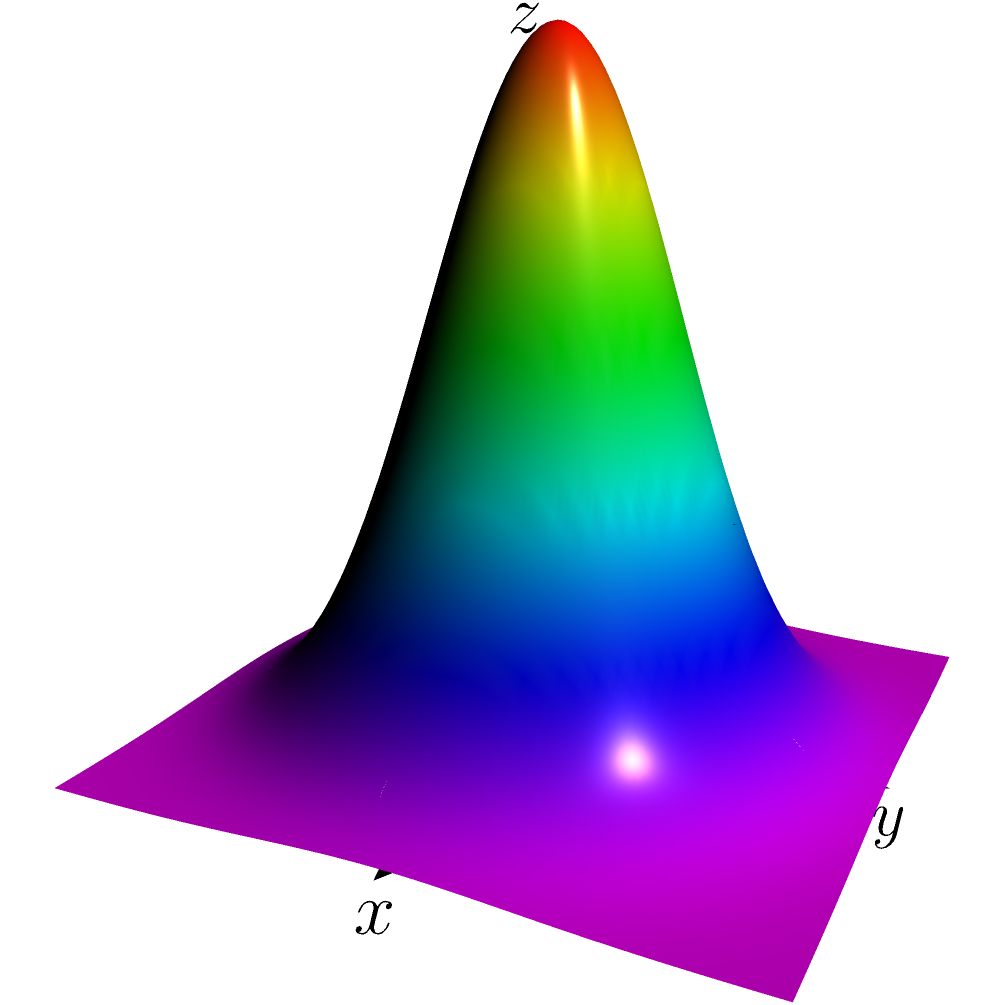You are tasked with creating a 3D surface plot of the function $f(x,y) = 2e^{-(x^2+y^2)}$ using Python's mplot3d. Which of the following code snippets would correctly generate this plot?

a) 
```python
import numpy as np
import matplotlib.pyplot as plt
from mpl_toolkits.mplot3d import Axes3D

x = np.linspace(-2, 2, 100)
y = np.linspace(-2, 2, 100)
X, Y = np.meshgrid(x, y)
Z = 2 * np.exp(-(X**2 + Y**2))

fig = plt.figure()
ax = fig.add_subplot(111, projection='3d')
ax.plot_surface(X, Y, Z)
plt.show()
```

b)
```python
import numpy as np
import matplotlib.pyplot as plt
from mpl_toolkits.mplot3d import Axes3D

x = np.linspace(-2, 2, 100)
y = np.linspace(-2, 2, 100)
X, Y = np.meshgrid(x, y)
Z = 2 * np.exp(-(X**2 + Y**2))

fig = plt.figure()
ax = fig.add_subplot(111, projection='3d')
ax.contour(X, Y, Z)
plt.show()
```

c)
```python
import numpy as np
import matplotlib.pyplot as plt

x = np.linspace(-2, 2, 100)
y = np.linspace(-2, 2, 100)
X, Y = np.meshgrid(x, y)
Z = 2 * np.exp(-(X**2 + Y**2))

plt.contourf(X, Y, Z)
plt.show()
```

d)
```python
import numpy as np
import matplotlib.pyplot as plt
from mpl_toolkits.mplot3d import Axes3D

x = np.linspace(-2, 2, 100)
y = np.linspace(-2, 2, 100)
X, Y = np.meshgrid(x, y)
Z = 2 * np.exp(-(X**2 + Y**2))

fig = plt.figure()
ax = fig.add_subplot(111, projection='3d')
ax.scatter(X, Y, Z)
plt.show()
``` Let's analyze each option:

1. Option (a):
   - Correctly imports necessary libraries (numpy, matplotlib.pyplot, mplot3d)
   - Creates a proper mesh grid using np.linspace and np.meshgrid
   - Correctly calculates Z values using the given function
   - Sets up a 3D subplot with `projection='3d'`
   - Uses `plot_surface()` which is the correct method for creating a 3D surface plot
   
2. Option (b):
   - Imports and setup are correct
   - However, it uses `ax.contour()` which creates a 2D contour plot, not a 3D surface plot

3. Option (c):
   - Does not import mplot3d
   - Uses `plt.contourf()` which creates a 2D filled contour plot, not a 3D surface plot

4. Option (d):
   - Imports and setup are correct
   - However, it uses `ax.scatter()` which creates a 3D scatter plot, not a continuous surface plot

The correct option is (a) because it properly sets up the 3D environment and uses the `plot_surface()` method to create a 3D surface plot of the given function.
Answer: a 